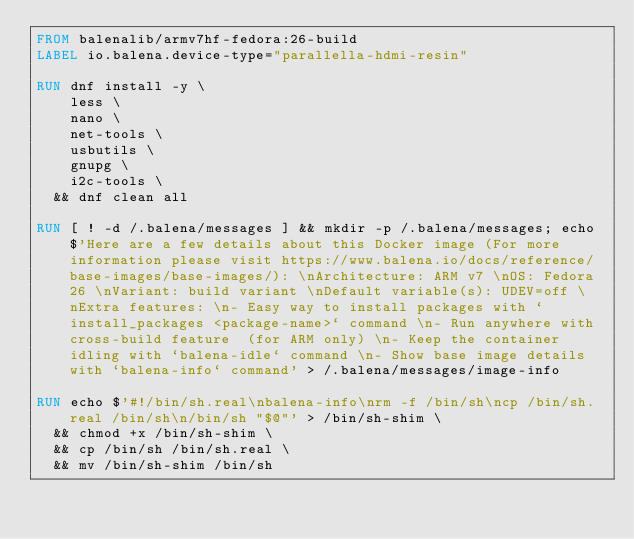<code> <loc_0><loc_0><loc_500><loc_500><_Dockerfile_>FROM balenalib/armv7hf-fedora:26-build
LABEL io.balena.device-type="parallella-hdmi-resin"

RUN dnf install -y \
		less \
		nano \
		net-tools \
		usbutils \
		gnupg \
		i2c-tools \
	&& dnf clean all

RUN [ ! -d /.balena/messages ] && mkdir -p /.balena/messages; echo $'Here are a few details about this Docker image (For more information please visit https://www.balena.io/docs/reference/base-images/base-images/): \nArchitecture: ARM v7 \nOS: Fedora 26 \nVariant: build variant \nDefault variable(s): UDEV=off \nExtra features: \n- Easy way to install packages with `install_packages <package-name>` command \n- Run anywhere with cross-build feature  (for ARM only) \n- Keep the container idling with `balena-idle` command \n- Show base image details with `balena-info` command' > /.balena/messages/image-info

RUN echo $'#!/bin/sh.real\nbalena-info\nrm -f /bin/sh\ncp /bin/sh.real /bin/sh\n/bin/sh "$@"' > /bin/sh-shim \
	&& chmod +x /bin/sh-shim \
	&& cp /bin/sh /bin/sh.real \
	&& mv /bin/sh-shim /bin/sh</code> 